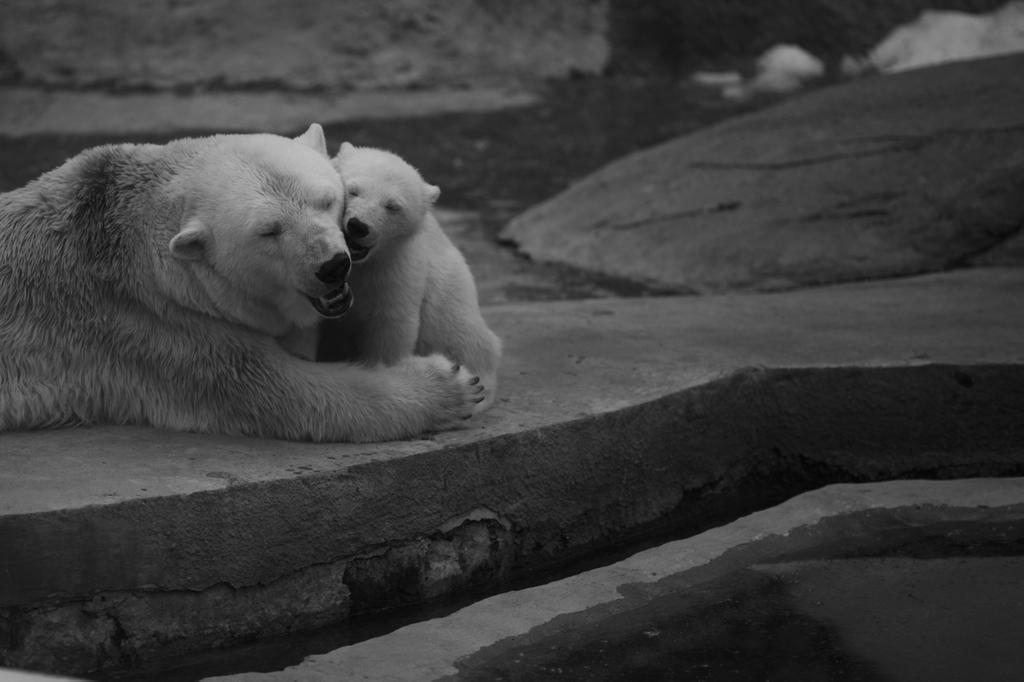How many bears are present in the image? There are two bears in the image. What can be seen in the background of the image? Water is visible in the image. What is the color scheme of the image? The image is in black and white. What type of crib is visible in the image? There is no crib present in the image; it features two bears and water in a black and white color scheme. 